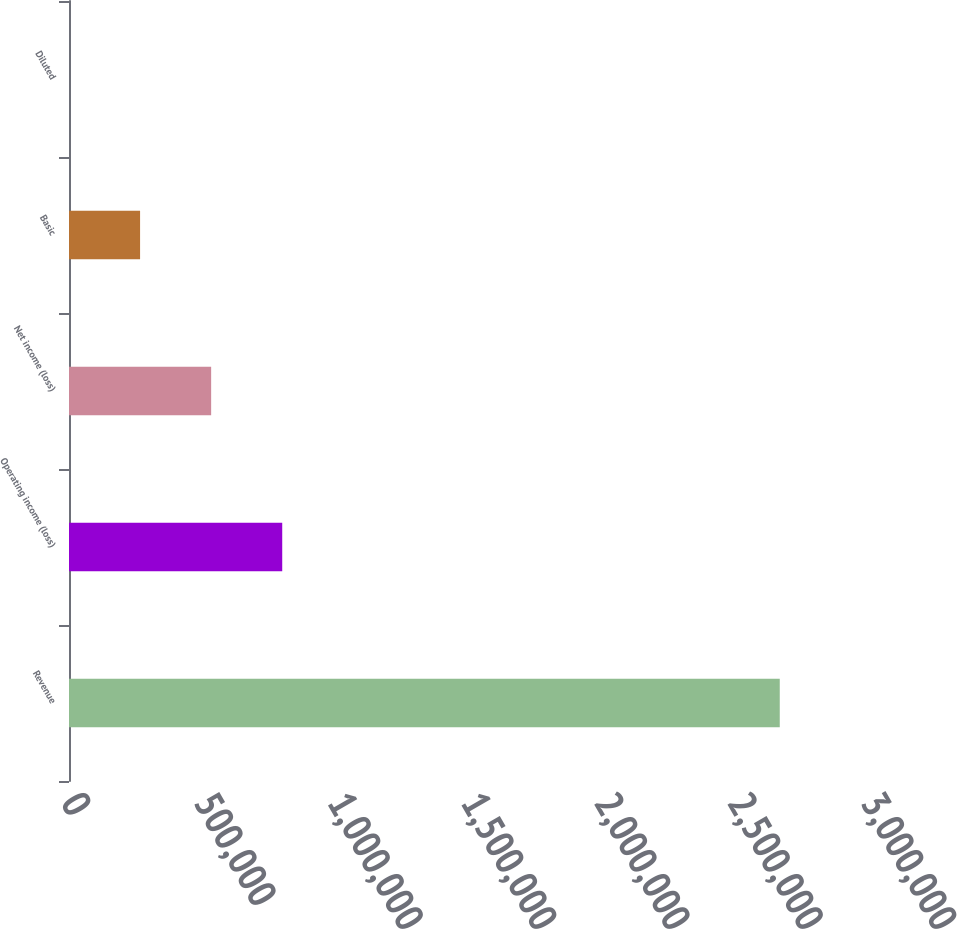<chart> <loc_0><loc_0><loc_500><loc_500><bar_chart><fcel>Revenue<fcel>Operating income (loss)<fcel>Net income (loss)<fcel>Basic<fcel>Diluted<nl><fcel>2.66533e+06<fcel>799600<fcel>533067<fcel>266534<fcel>0.94<nl></chart> 